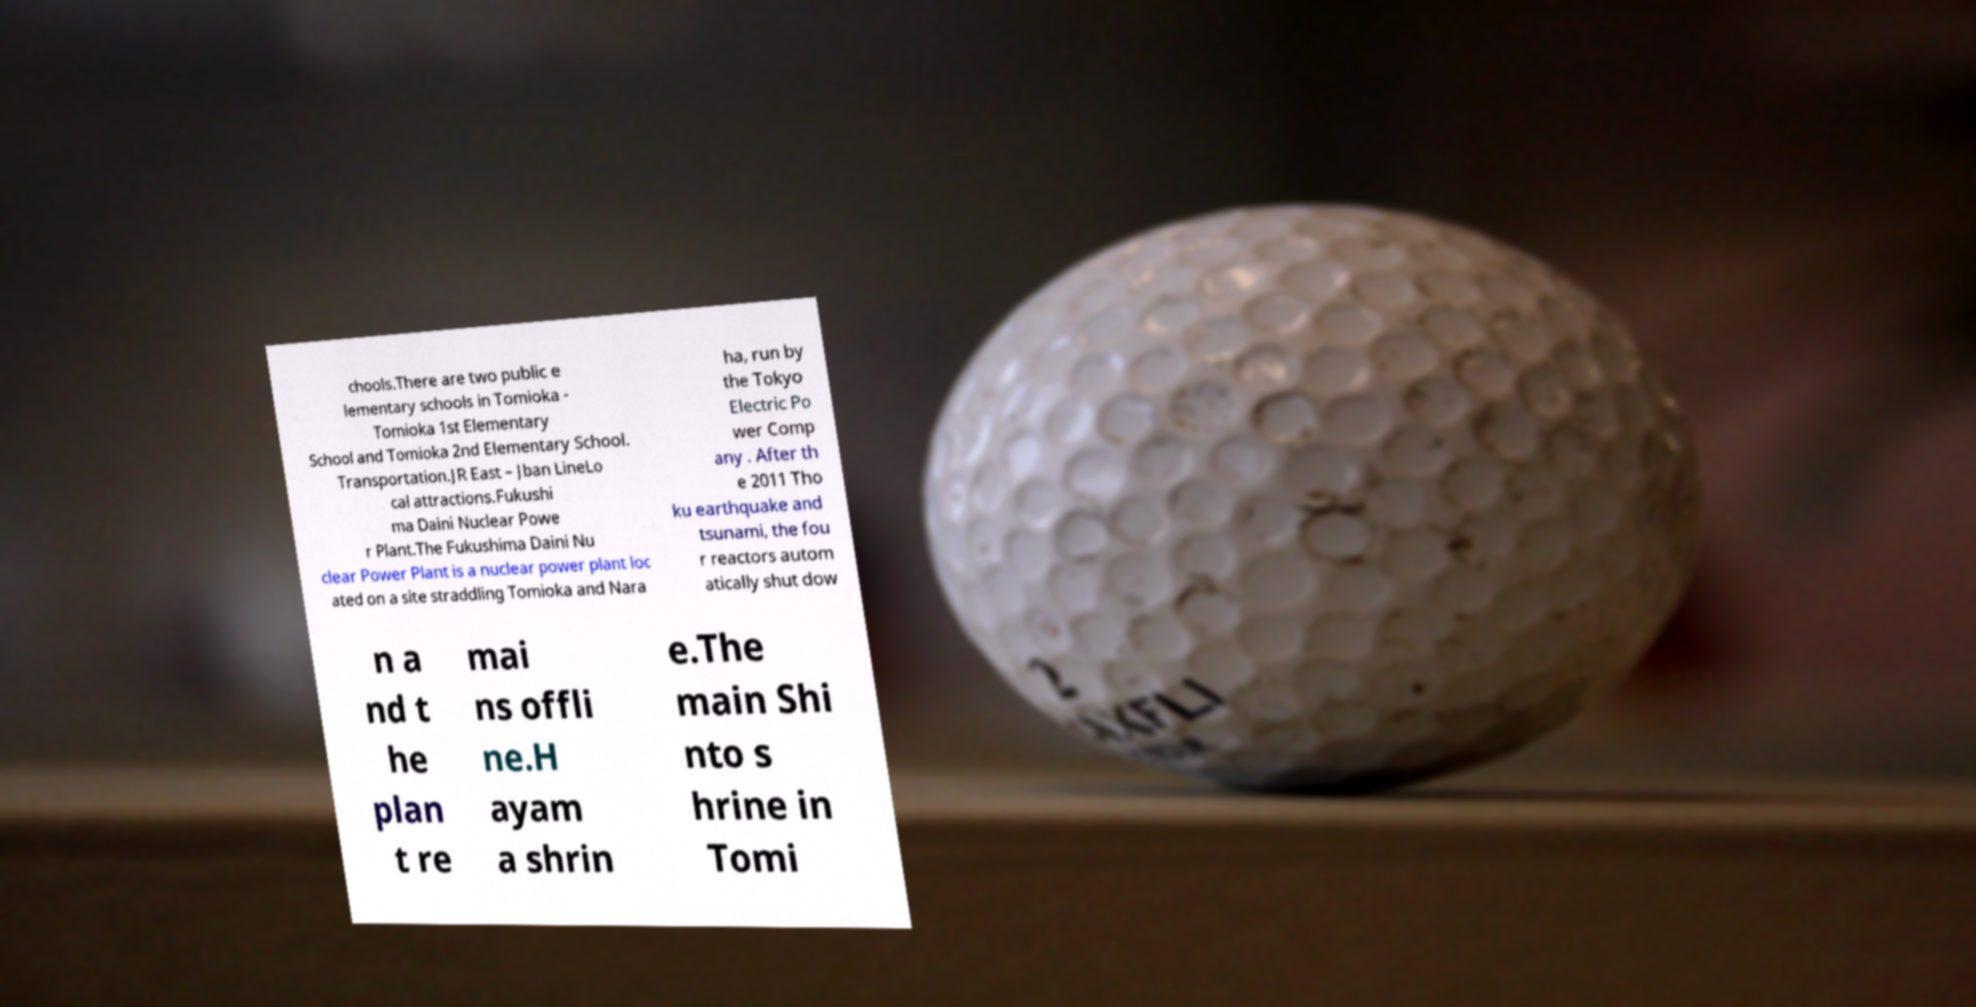There's text embedded in this image that I need extracted. Can you transcribe it verbatim? chools.There are two public e lementary schools in Tomioka - Tomioka 1st Elementary School and Tomioka 2nd Elementary School. Transportation.JR East – Jban LineLo cal attractions.Fukushi ma Daini Nuclear Powe r Plant.The Fukushima Daini Nu clear Power Plant is a nuclear power plant loc ated on a site straddling Tomioka and Nara ha, run by the Tokyo Electric Po wer Comp any . After th e 2011 Tho ku earthquake and tsunami, the fou r reactors autom atically shut dow n a nd t he plan t re mai ns offli ne.H ayam a shrin e.The main Shi nto s hrine in Tomi 